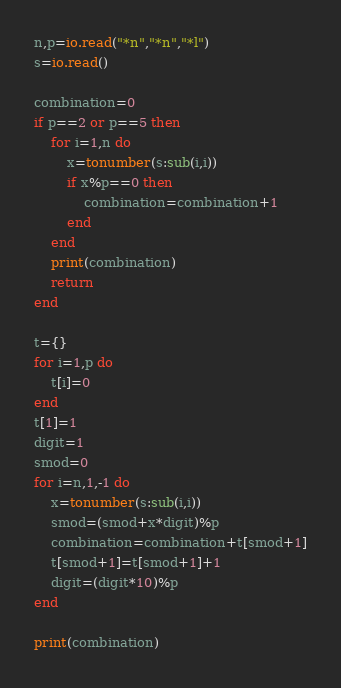Convert code to text. <code><loc_0><loc_0><loc_500><loc_500><_Lua_>n,p=io.read("*n","*n","*l")
s=io.read()

combination=0
if p==2 or p==5 then
    for i=1,n do
        x=tonumber(s:sub(i,i))
        if x%p==0 then
            combination=combination+1
        end
    end
    print(combination)
    return
end

t={}
for i=1,p do
    t[i]=0
end
t[1]=1
digit=1
smod=0
for i=n,1,-1 do
    x=tonumber(s:sub(i,i))
    smod=(smod+x*digit)%p
    combination=combination+t[smod+1]
    t[smod+1]=t[smod+1]+1
    digit=(digit*10)%p
end

print(combination)</code> 